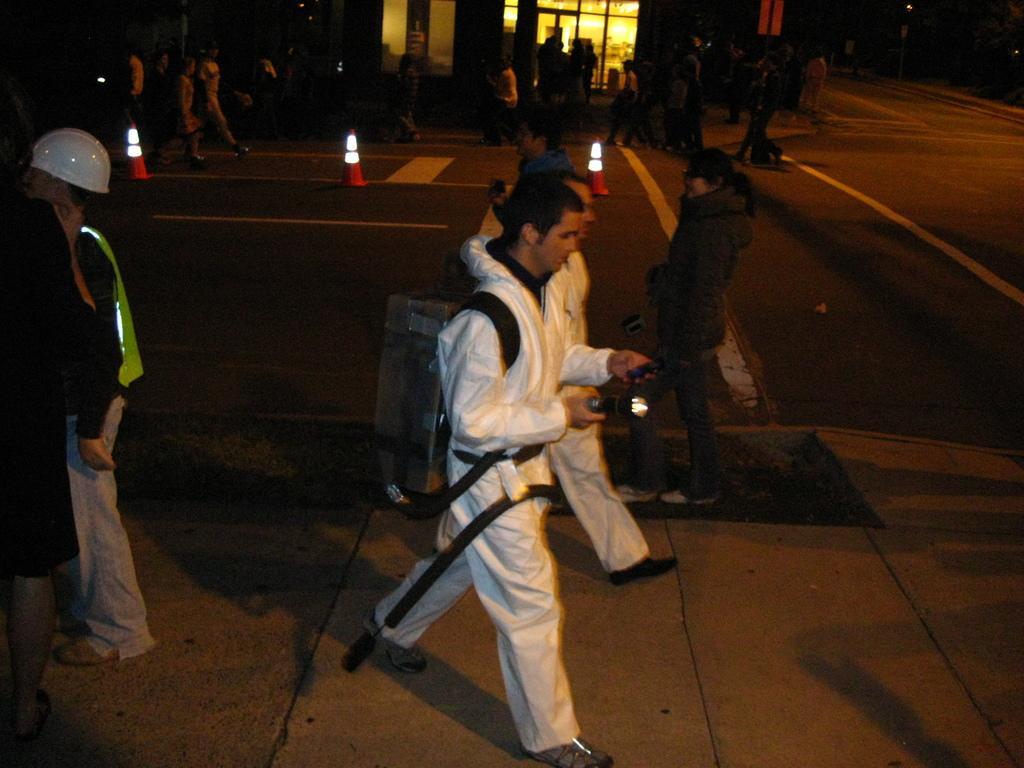Describe this image in one or two sentences. In the picture we can see a road and near it we can see a path with two people are walking they are in white dress and one man is wearing a white helmet standing behind them and on the opposite side we can see some people are walking here and there and behind them we can see a building wall with glass to it and inside we can see lights. 